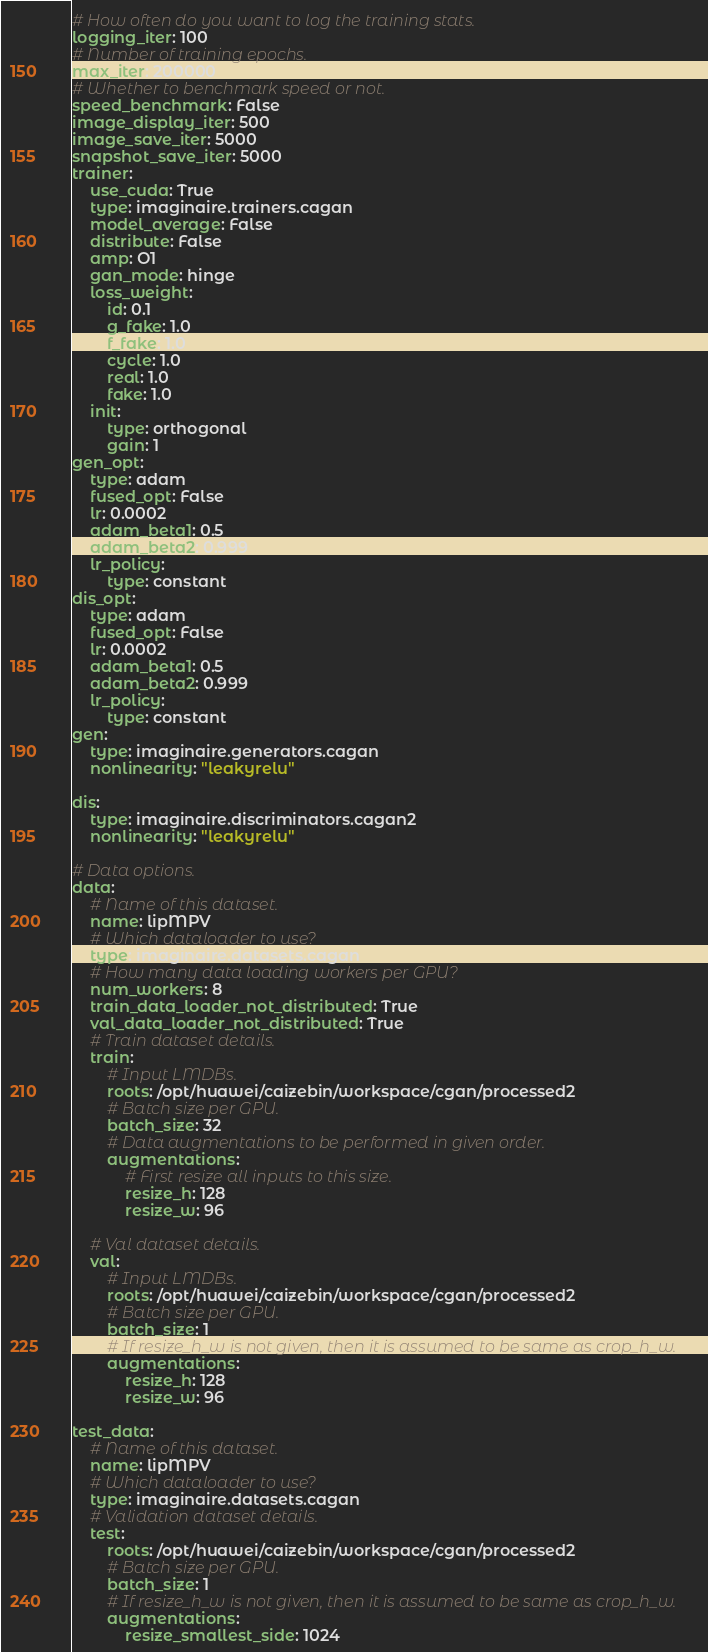Convert code to text. <code><loc_0><loc_0><loc_500><loc_500><_YAML_># How often do you want to log the training stats.
logging_iter: 100
# Number of training epochs.
max_iter: 200000
# Whether to benchmark speed or not.
speed_benchmark: False
image_display_iter: 500
image_save_iter: 5000
snapshot_save_iter: 5000
trainer:
    use_cuda: True
    type: imaginaire.trainers.cagan
    model_average: False
    distribute: False
    amp: O1
    gan_mode: hinge
    loss_weight:
        id: 0.1
        g_fake: 1.0
        f_fake: 1.0
        cycle: 1.0
        real: 1.0
        fake: 1.0
    init:
        type: orthogonal
        gain: 1
gen_opt:
    type: adam
    fused_opt: False
    lr: 0.0002
    adam_beta1: 0.5
    adam_beta2: 0.999
    lr_policy:
        type: constant
dis_opt:
    type: adam
    fused_opt: False
    lr: 0.0002
    adam_beta1: 0.5
    adam_beta2: 0.999
    lr_policy:
        type: constant
gen:
    type: imaginaire.generators.cagan
    nonlinearity: "leakyrelu"

dis:
    type: imaginaire.discriminators.cagan2
    nonlinearity: "leakyrelu"

# Data options.
data:
    # Name of this dataset.
    name: lipMPV
    # Which dataloader to use?
    type: imaginaire.datasets.cagan
    # How many data loading workers per GPU?
    num_workers: 8
    train_data_loader_not_distributed: True
    val_data_loader_not_distributed: True
    # Train dataset details.
    train:
        # Input LMDBs.
        roots: /opt/huawei/caizebin/workspace/cgan/processed2
        # Batch size per GPU.
        batch_size: 32
        # Data augmentations to be performed in given order.
        augmentations:
            # First resize all inputs to this size.
            resize_h: 128
            resize_w: 96

    # Val dataset details.
    val:
        # Input LMDBs.
        roots: /opt/huawei/caizebin/workspace/cgan/processed2
        # Batch size per GPU.
        batch_size: 1
        # If resize_h_w is not given, then it is assumed to be same as crop_h_w.
        augmentations:
            resize_h: 128
            resize_w: 96

test_data:
    # Name of this dataset.
    name: lipMPV
    # Which dataloader to use?
    type: imaginaire.datasets.cagan
    # Validation dataset details.
    test:
        roots: /opt/huawei/caizebin/workspace/cgan/processed2
        # Batch size per GPU.
        batch_size: 1
        # If resize_h_w is not given, then it is assumed to be same as crop_h_w.
        augmentations:
            resize_smallest_side: 1024
</code> 